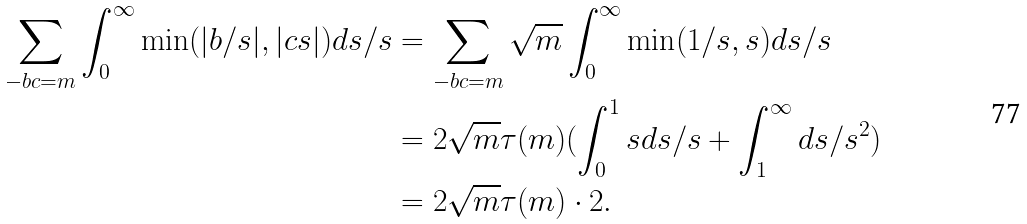Convert formula to latex. <formula><loc_0><loc_0><loc_500><loc_500>\sum _ { - b c = m } \int _ { 0 } ^ { \infty } \min ( | b / s | , | c s | ) d s / s & = \sum _ { - b c = m } \sqrt { m } \int _ { 0 } ^ { \infty } \min ( 1 / s , s ) d s / s \\ & = 2 \sqrt { m } \tau ( m ) ( \int _ { 0 } ^ { 1 } s d s / s + \int _ { 1 } ^ { \infty } d s / s ^ { 2 } ) \\ & = 2 \sqrt { m } \tau ( m ) \cdot 2 .</formula> 